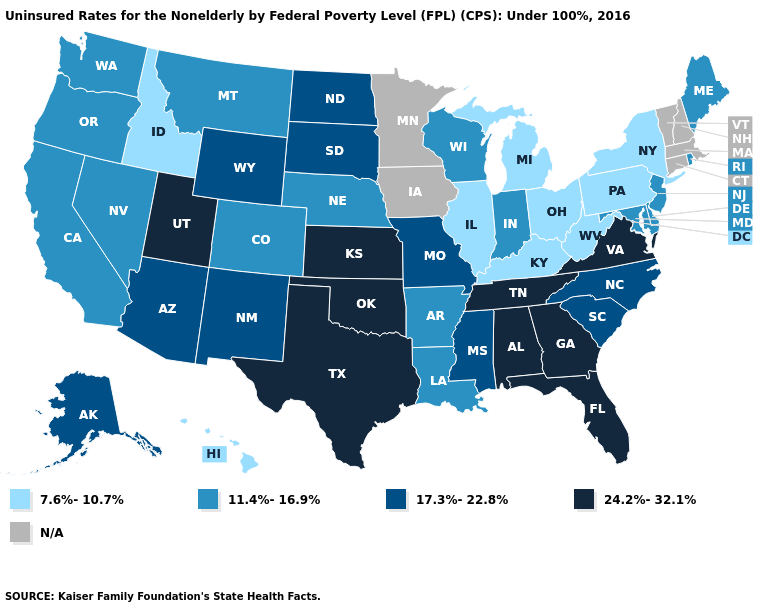Which states have the lowest value in the West?
Keep it brief. Hawaii, Idaho. What is the highest value in states that border Pennsylvania?
Keep it brief. 11.4%-16.9%. Which states hav the highest value in the MidWest?
Short answer required. Kansas. Does the first symbol in the legend represent the smallest category?
Concise answer only. Yes. What is the value of Illinois?
Short answer required. 7.6%-10.7%. Name the states that have a value in the range 17.3%-22.8%?
Keep it brief. Alaska, Arizona, Mississippi, Missouri, New Mexico, North Carolina, North Dakota, South Carolina, South Dakota, Wyoming. Does the first symbol in the legend represent the smallest category?
Give a very brief answer. Yes. Does Oklahoma have the highest value in the South?
Short answer required. Yes. Name the states that have a value in the range 17.3%-22.8%?
Give a very brief answer. Alaska, Arizona, Mississippi, Missouri, New Mexico, North Carolina, North Dakota, South Carolina, South Dakota, Wyoming. Name the states that have a value in the range 11.4%-16.9%?
Be succinct. Arkansas, California, Colorado, Delaware, Indiana, Louisiana, Maine, Maryland, Montana, Nebraska, Nevada, New Jersey, Oregon, Rhode Island, Washington, Wisconsin. What is the lowest value in the West?
Keep it brief. 7.6%-10.7%. Does the map have missing data?
Answer briefly. Yes. Among the states that border Texas , does New Mexico have the lowest value?
Give a very brief answer. No. 